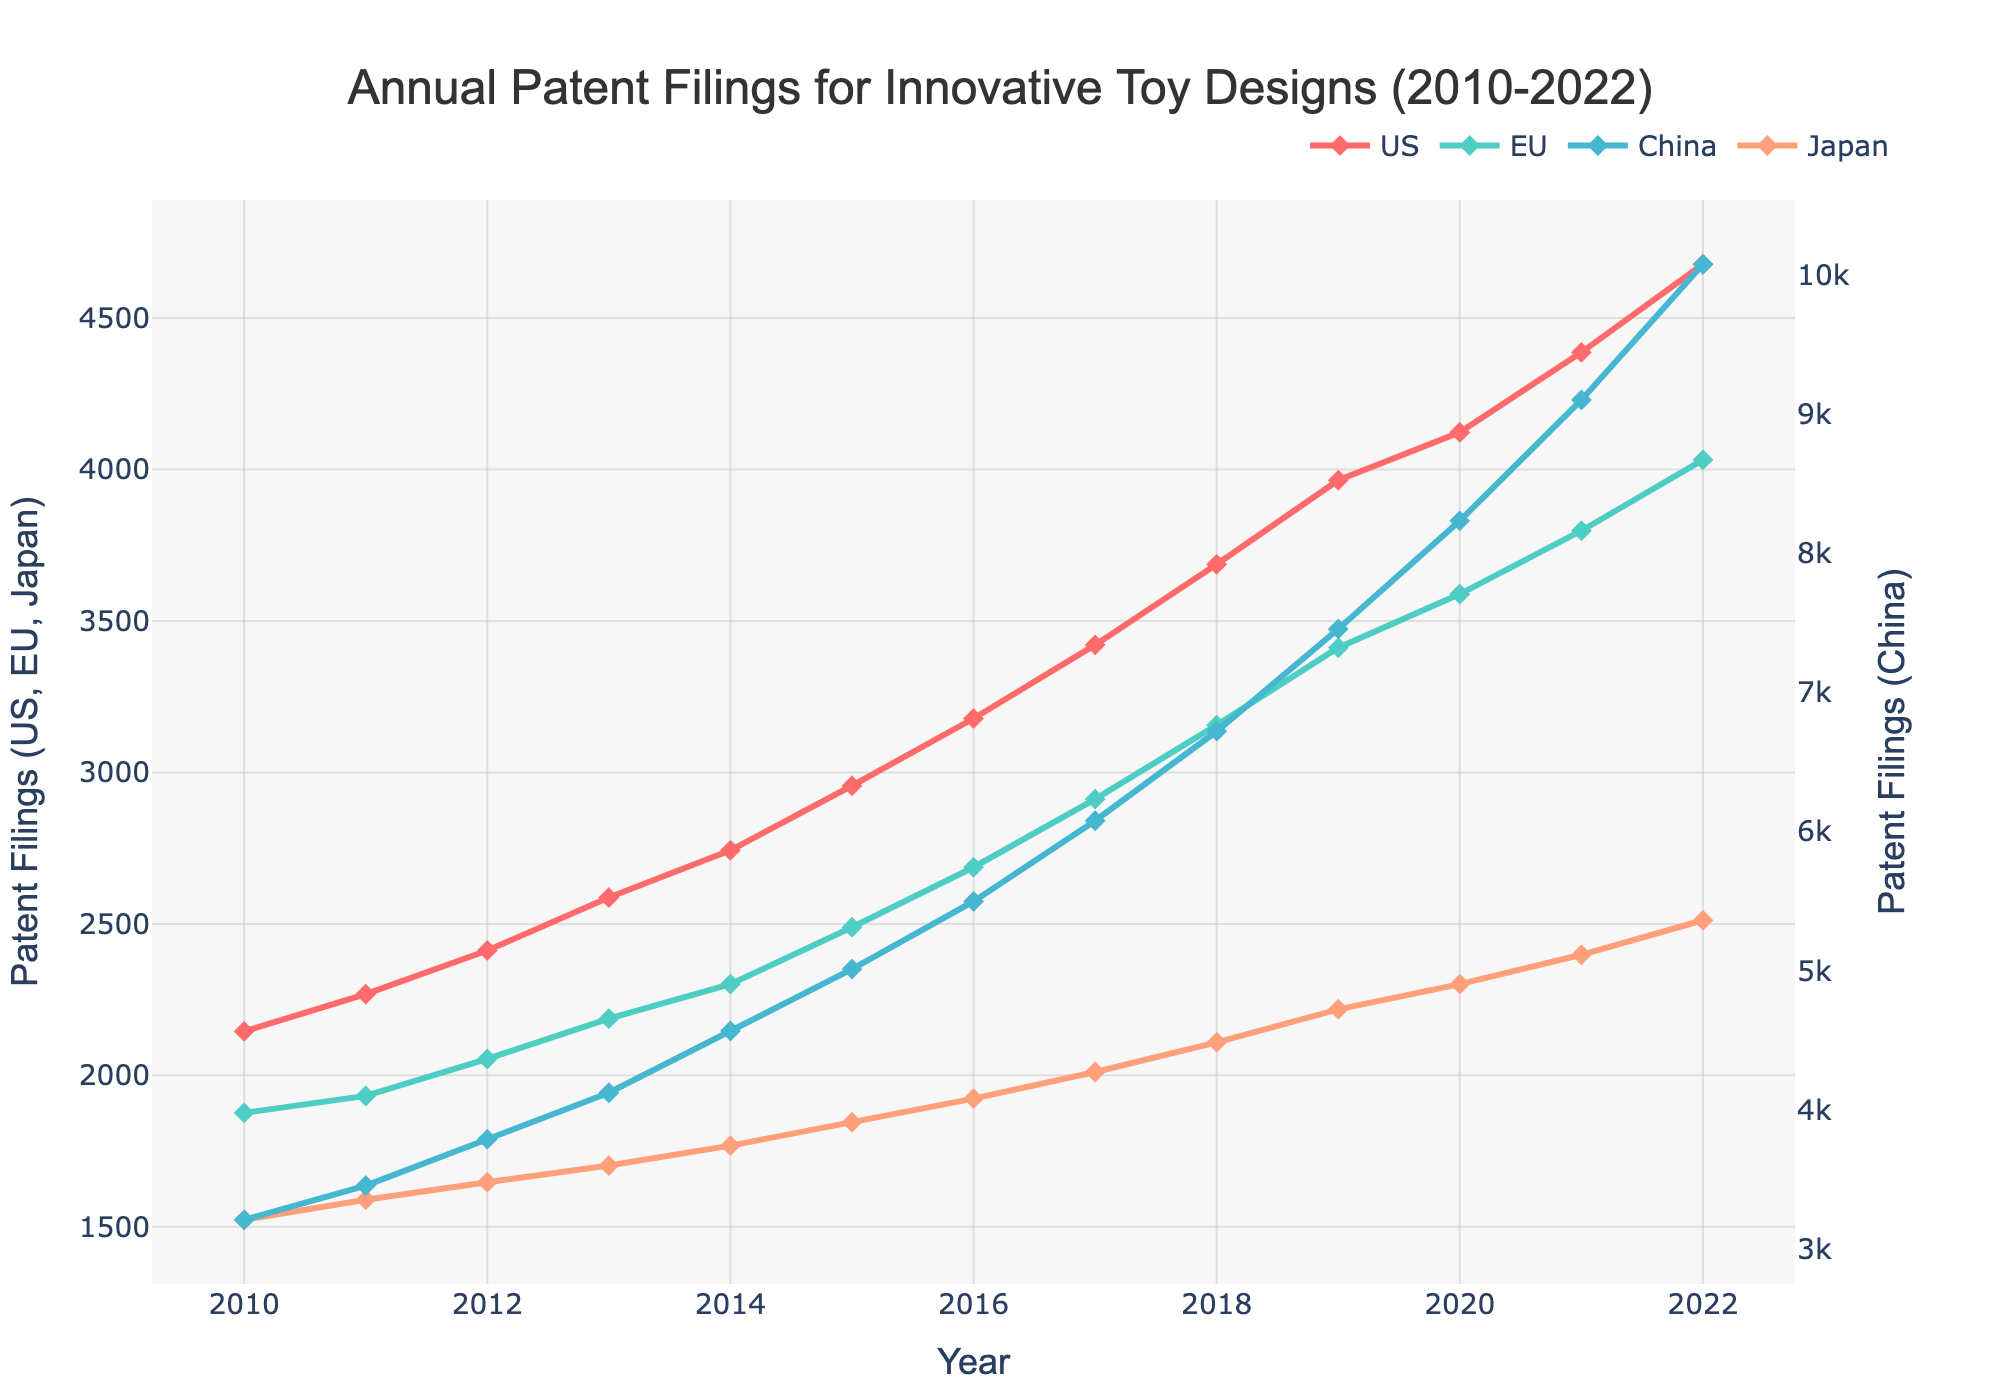Which region had the highest number of patent filings in 2022? By looking at the graph, identify the line that seems to be the highest in 2022. China's line (depicted in blue) peaks at 10078, which is higher than other regions.
Answer: China How much did the patent filings for the US increase from 2010 to 2022? Locate the values for the US in 2010 and 2022. Subtract the 2010 value from the 2022 value: 4678 - 2145 = 2533.
Answer: 2533 Between which years did the EU see the largest increase in patent filings? Observe the EU line for steepness between consecutive years. The largest jump is between 2019 (3412) and 2020 (3589) for an increase of 177.
Answer: 2019-2020 What is the average number of patent filings for Japan between 2010 and 2022? Add the values for Japan from 2010 to 2022 and divide by the number of years (13). Sum: 1523 + 1589 + 1647 + 1702 + 1768 + 1845 + 1923 + 2011 + 2109 + 2218 + 2301 + 2398 + 2512 = 26546. Average: 26546 / 13 = 2042.
Answer: 2042 During which year did China overtake the sum of US and EU filings? Check each year by comparing China's value with the sum of US and EU values. In 2015, China (5012) surpasses US + EU (2956 + 2489 = 5445), and from 2016 onwards, it exceeds consistently.
Answer: 2015 Which year showed the first divergence in the growth rate between China's and Japan's patent filings? Identify when the lines for China and Japan start sharply diverging. The chart shows a significant divergence starting around 2016.
Answer: 2016 How does the sum of patent filings in the EU in 2012 compare to China in 2011? Sum the EU's filings for 2012 and compare with China's filings for 2011. EU in 2012: 2054. China in 2011: 3456. The value for China is higher.
Answer: China’s filings higher What is the total number of patent filings for all regions combined in 2022? Sum the filings for US, EU, China, and Japan in 2022: 4678 + 4032 + 10078 + 2512 = 21200.
Answer: 21200 In which year did US filings first exceed 3000? Check the US line for when it crosses 3000. It first exceeds 3000 in 2016.
Answer: 2016 From 2010 to 2022, which region had the most consistent annual growth in patent filings? Visually, evaluate which line has the most consistent upward trend without large fluctuations. The US and EU lines appear consistent, but EU's filings proceed at a steadier increment annually.
Answer: EU 